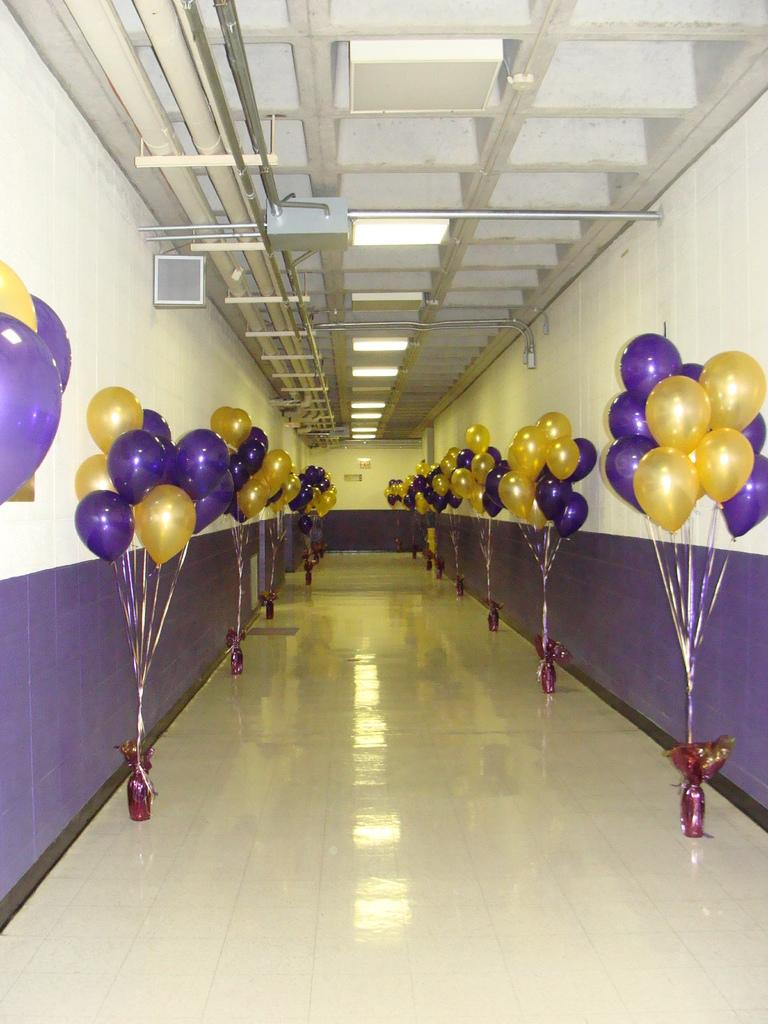What objects are present in the image that are filled with air? There are balloons in the image. How are the balloons connected to other objects? The balloons are attached to bottles. Where are the bottles located in the image? The bottles are on the floor in a row. What can be seen behind the bottles in the image? There is a wall behind the bottles. What type of office does the lawyer work in, as seen in the image? There is no office or lawyer present in the image; it only features balloons, bottles, and a wall. 